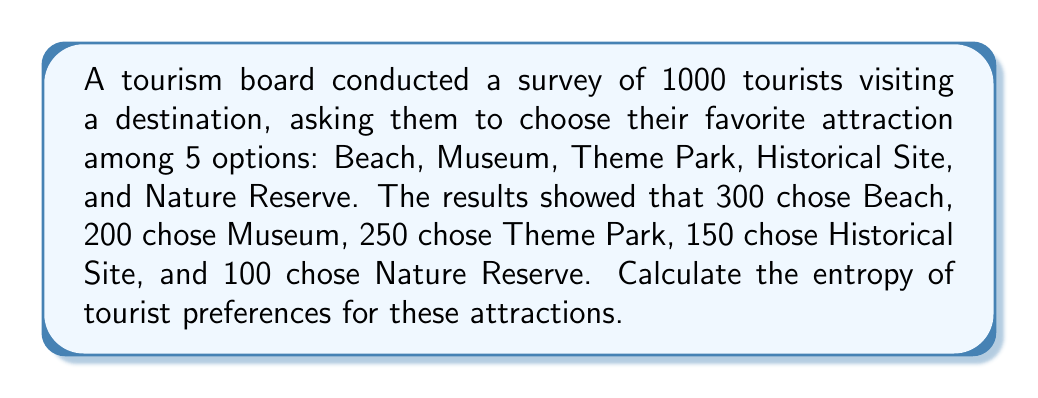Can you answer this question? To calculate the entropy of tourist preferences, we'll use the Shannon entropy formula:

$$S = -\sum_{i=1}^{n} p_i \log_2(p_i)$$

Where $S$ is the entropy, $p_i$ is the probability of each outcome, and $n$ is the number of possible outcomes.

Step 1: Calculate the probabilities for each attraction:
$p_{\text{Beach}} = 300/1000 = 0.3$
$p_{\text{Museum}} = 200/1000 = 0.2$
$p_{\text{Theme Park}} = 250/1000 = 0.25$
$p_{\text{Historical Site}} = 150/1000 = 0.15$
$p_{\text{Nature Reserve}} = 100/1000 = 0.1$

Step 2: Apply the entropy formula:
$$\begin{align*}
S &= -[0.3 \log_2(0.3) + 0.2 \log_2(0.2) + 0.25 \log_2(0.25) \\
&+ 0.15 \log_2(0.15) + 0.1 \log_2(0.1)]
\end{align*}$$

Step 3: Calculate each term:
$0.3 \log_2(0.3) \approx -0.5211$
$0.2 \log_2(0.2) \approx -0.4644$
$0.25 \log_2(0.25) \approx -0.5$
$0.15 \log_2(0.15) \approx -0.4101$
$0.1 \log_2(0.1) \approx -0.3322$

Step 4: Sum the terms and take the negative:
$$S = -(-0.5211 - 0.4644 - 0.5 - 0.4101 - 0.3322) \approx 2.2278$$

The entropy of tourist preferences is approximately 2.2278 bits.
Answer: 2.2278 bits 